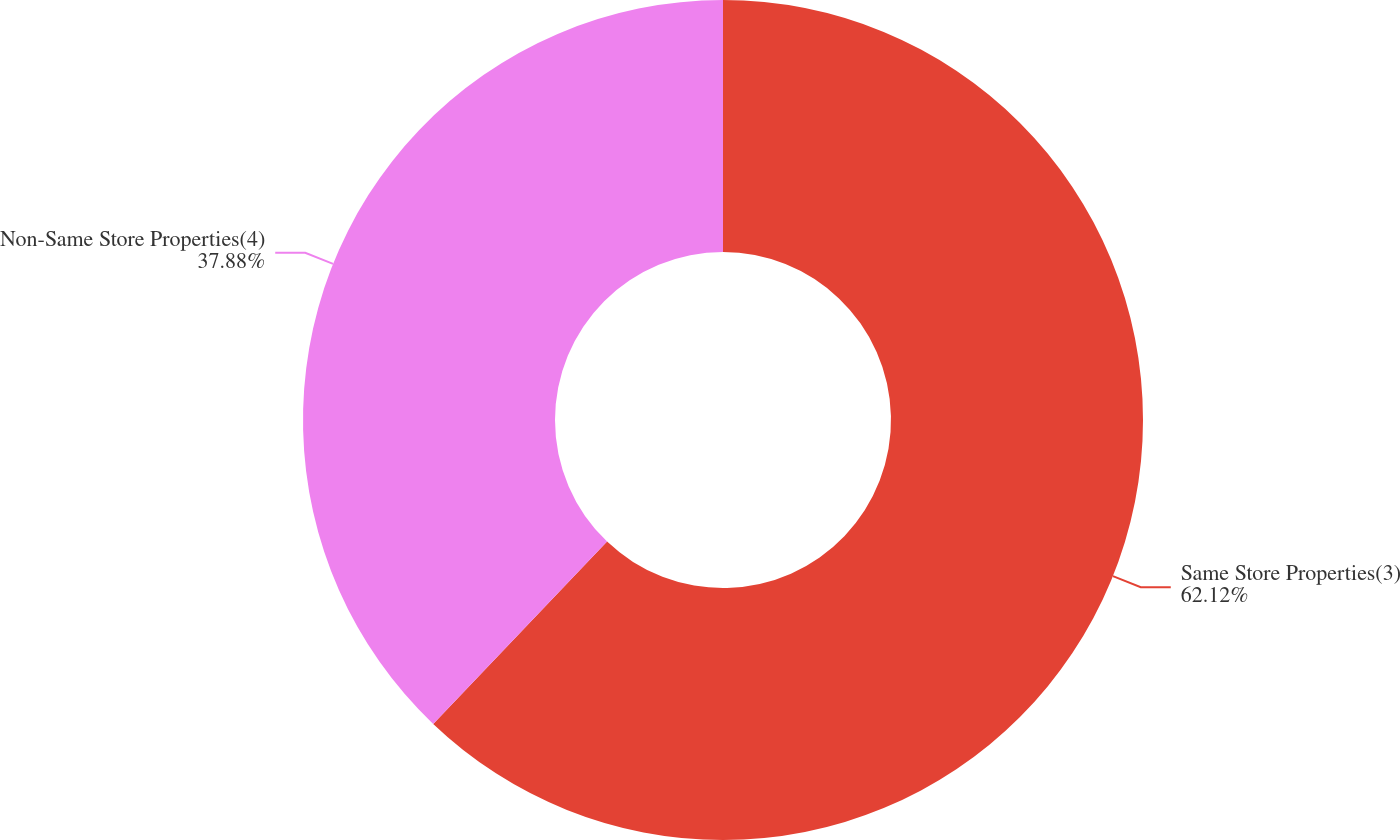Convert chart. <chart><loc_0><loc_0><loc_500><loc_500><pie_chart><fcel>Same Store Properties(3)<fcel>Non-Same Store Properties(4)<nl><fcel>62.12%<fcel>37.88%<nl></chart> 